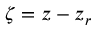Convert formula to latex. <formula><loc_0><loc_0><loc_500><loc_500>\zeta = z - z _ { r }</formula> 